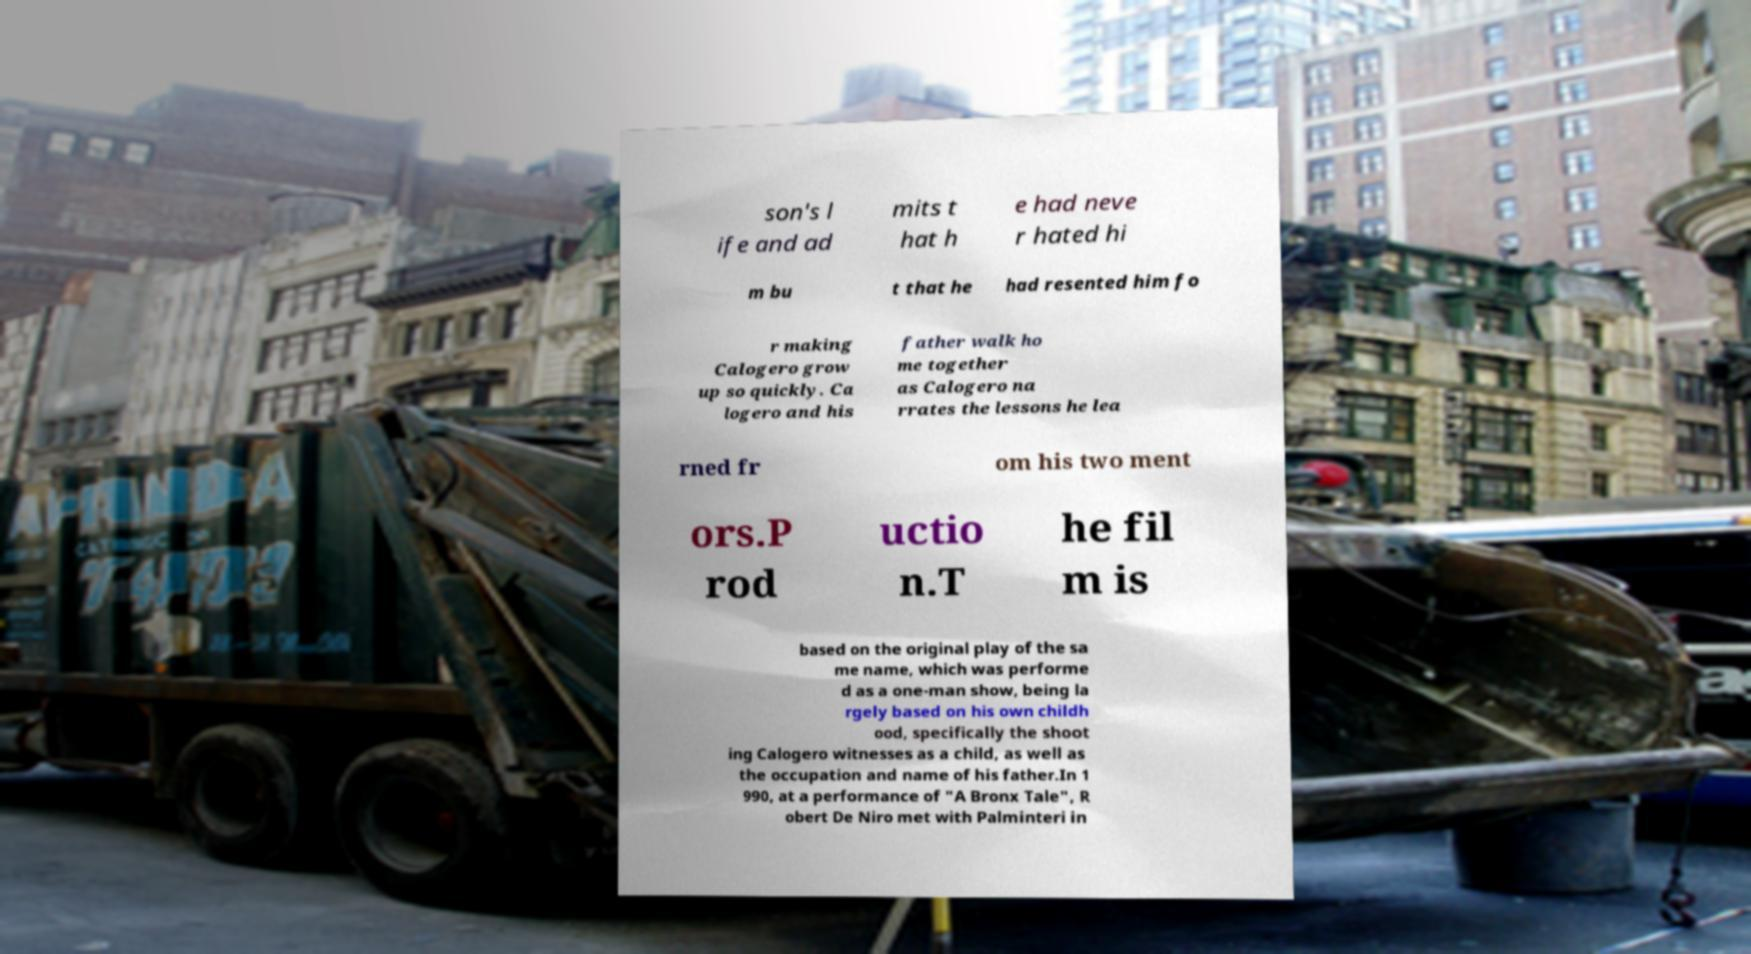Can you read and provide the text displayed in the image?This photo seems to have some interesting text. Can you extract and type it out for me? son's l ife and ad mits t hat h e had neve r hated hi m bu t that he had resented him fo r making Calogero grow up so quickly. Ca logero and his father walk ho me together as Calogero na rrates the lessons he lea rned fr om his two ment ors.P rod uctio n.T he fil m is based on the original play of the sa me name, which was performe d as a one-man show, being la rgely based on his own childh ood, specifically the shoot ing Calogero witnesses as a child, as well as the occupation and name of his father.In 1 990, at a performance of "A Bronx Tale", R obert De Niro met with Palminteri in 